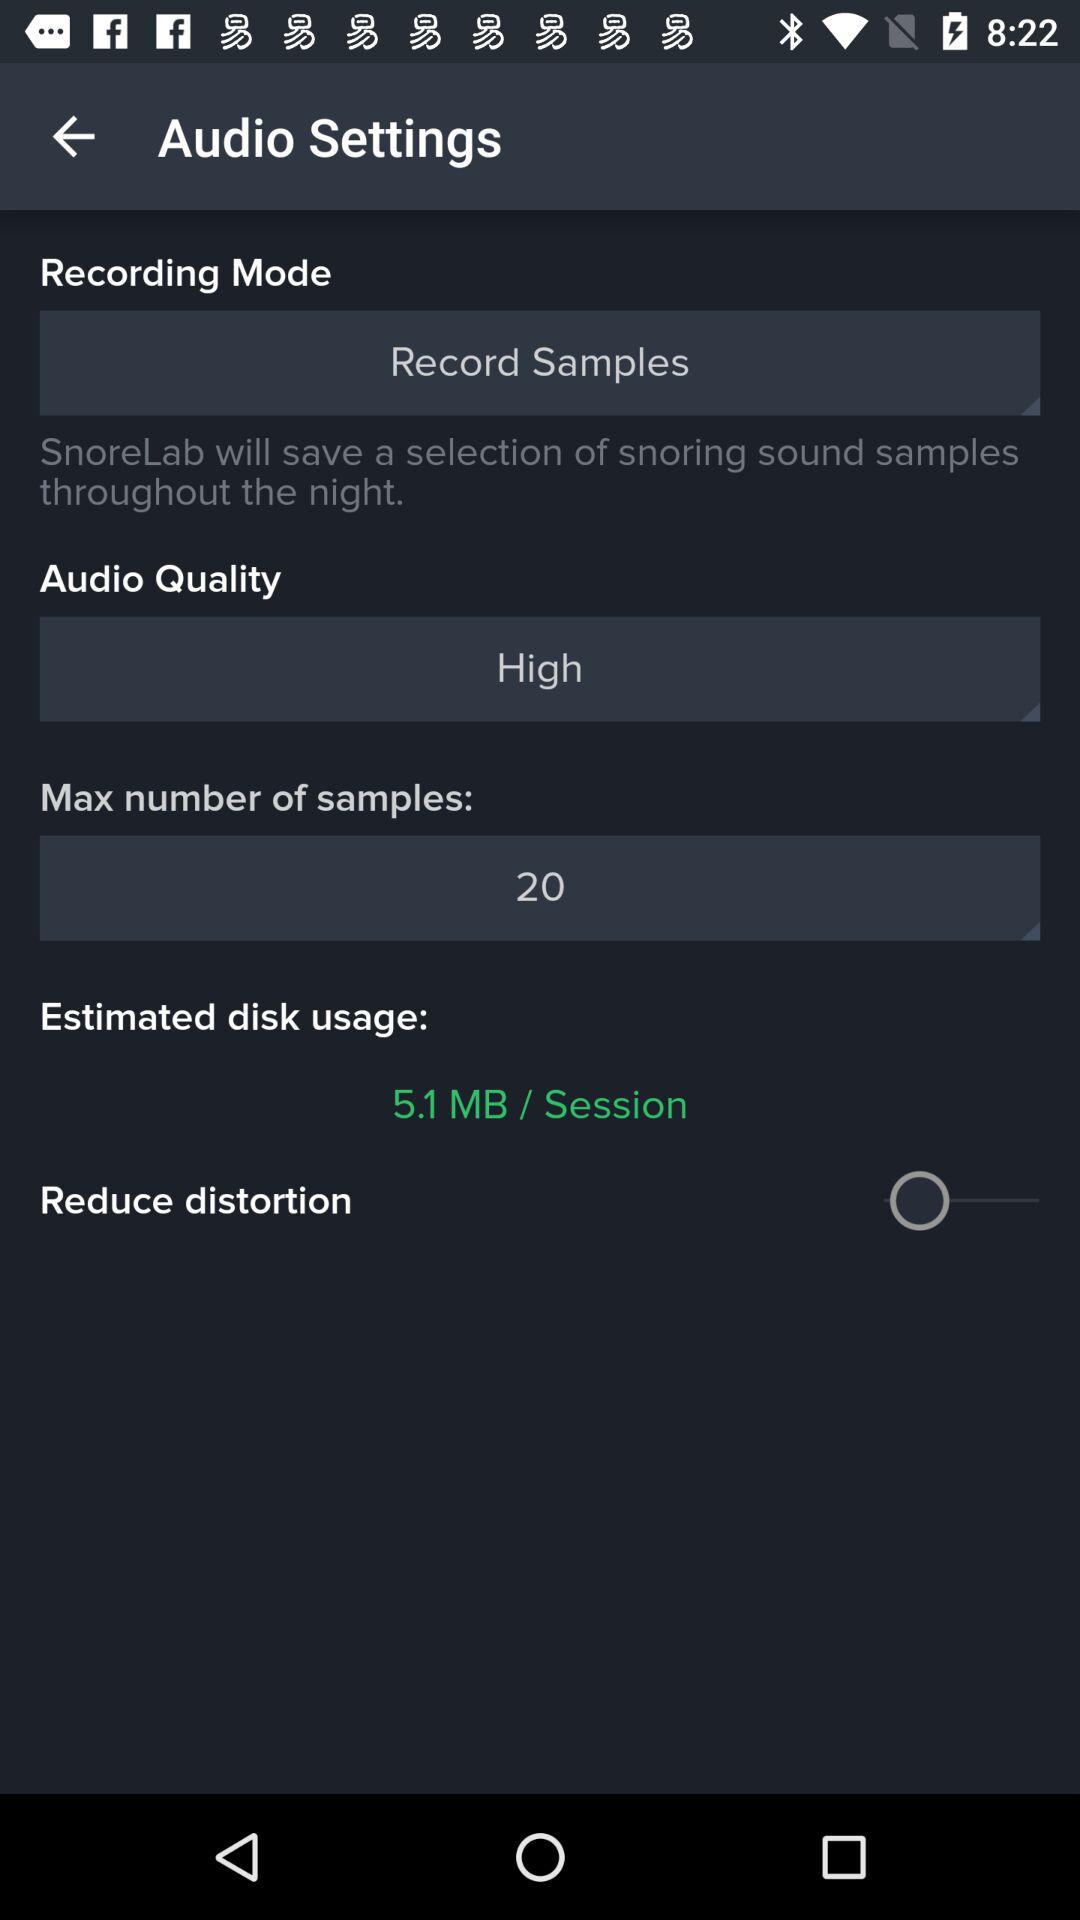What is the estimated disk usage? The estimated disk usage is 5.1 MB/session. 